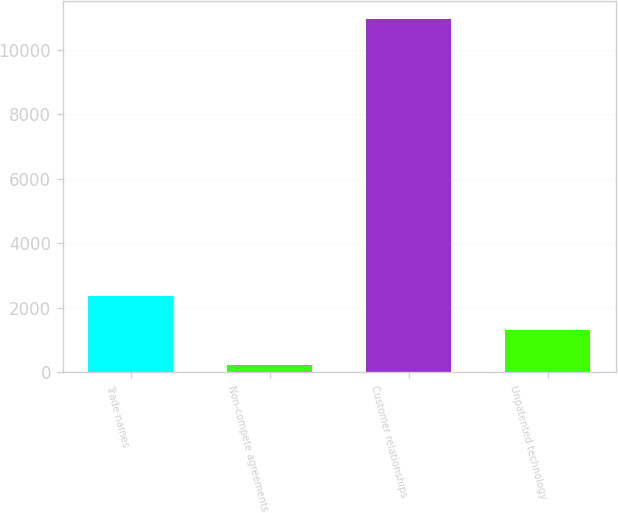Convert chart. <chart><loc_0><loc_0><loc_500><loc_500><bar_chart><fcel>Trade names<fcel>Non-compete agreements<fcel>Customer relationships<fcel>Unpatented technology<nl><fcel>2369.2<fcel>224<fcel>10950<fcel>1296.6<nl></chart> 